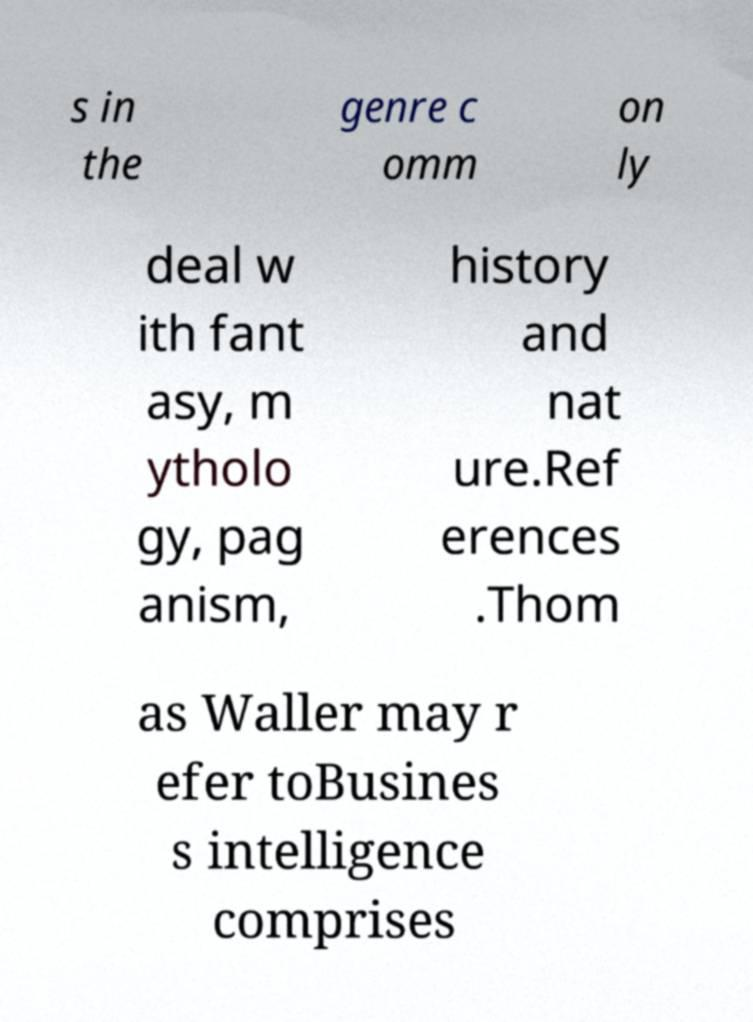Could you assist in decoding the text presented in this image and type it out clearly? s in the genre c omm on ly deal w ith fant asy, m ytholo gy, pag anism, history and nat ure.Ref erences .Thom as Waller may r efer toBusines s intelligence comprises 